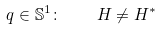Convert formula to latex. <formula><loc_0><loc_0><loc_500><loc_500>q \in \mathbb { S } ^ { 1 } \colon \quad H \neq H ^ { \ast }</formula> 